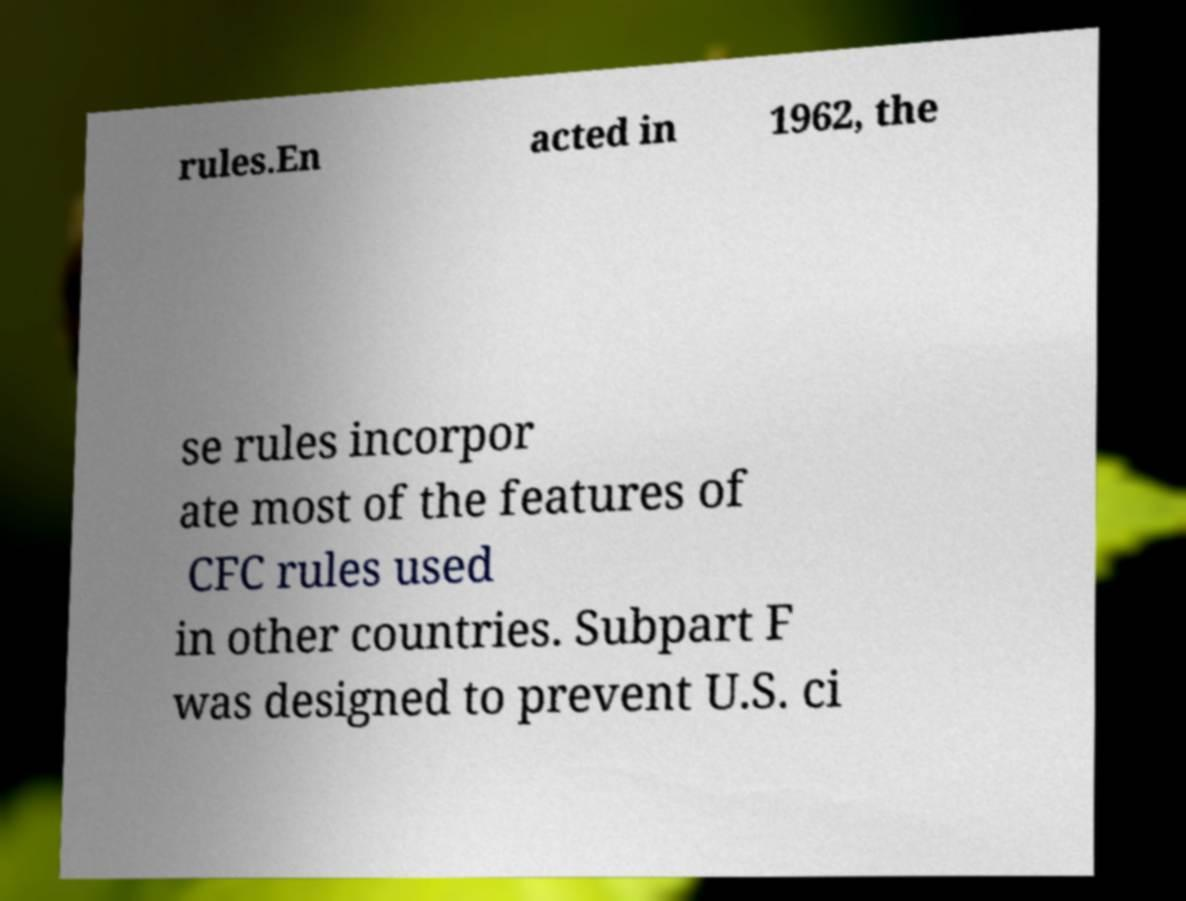What messages or text are displayed in this image? I need them in a readable, typed format. rules.En acted in 1962, the se rules incorpor ate most of the features of CFC rules used in other countries. Subpart F was designed to prevent U.S. ci 